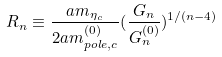<formula> <loc_0><loc_0><loc_500><loc_500>R _ { n } \equiv \frac { a m _ { \eta _ { c } } } { 2 a m ^ { ( 0 ) } _ { p o l e , c } } ( \frac { G _ { n } } { G _ { n } ^ { ( 0 ) } } ) ^ { 1 / ( n - 4 ) }</formula> 